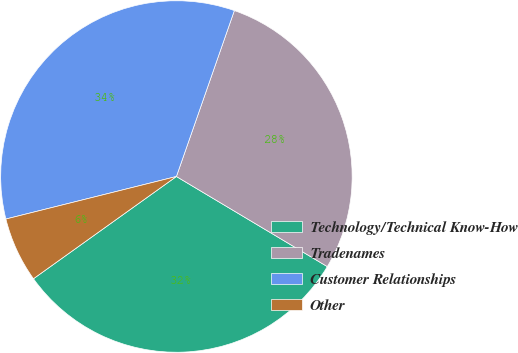Convert chart to OTSL. <chart><loc_0><loc_0><loc_500><loc_500><pie_chart><fcel>Technology/Technical Know-How<fcel>Tradenames<fcel>Customer Relationships<fcel>Other<nl><fcel>31.55%<fcel>28.22%<fcel>34.24%<fcel>5.99%<nl></chart> 